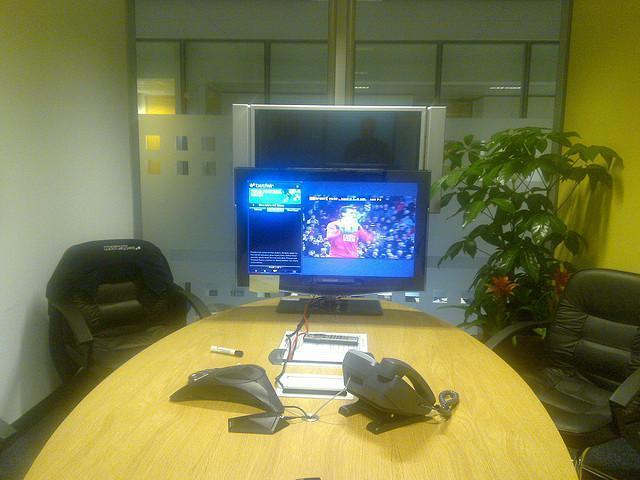Is the caption "The dining table is near the person." a true representation of the image?
Answer yes or no. No. 